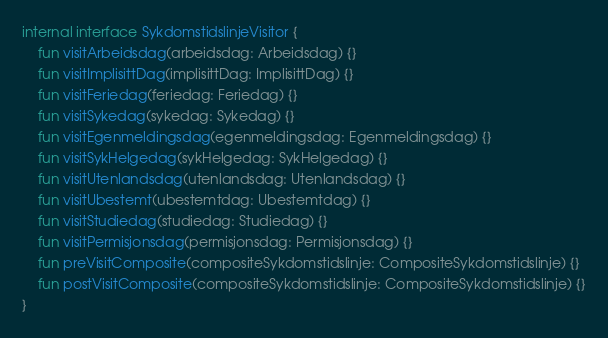Convert code to text. <code><loc_0><loc_0><loc_500><loc_500><_Kotlin_>internal interface SykdomstidslinjeVisitor {
    fun visitArbeidsdag(arbeidsdag: Arbeidsdag) {}
    fun visitImplisittDag(implisittDag: ImplisittDag) {}
    fun visitFeriedag(feriedag: Feriedag) {}
    fun visitSykedag(sykedag: Sykedag) {}
    fun visitEgenmeldingsdag(egenmeldingsdag: Egenmeldingsdag) {}
    fun visitSykHelgedag(sykHelgedag: SykHelgedag) {}
    fun visitUtenlandsdag(utenlandsdag: Utenlandsdag) {}
    fun visitUbestemt(ubestemtdag: Ubestemtdag) {}
    fun visitStudiedag(studiedag: Studiedag) {}
    fun visitPermisjonsdag(permisjonsdag: Permisjonsdag) {}
    fun preVisitComposite(compositeSykdomstidslinje: CompositeSykdomstidslinje) {}
    fun postVisitComposite(compositeSykdomstidslinje: CompositeSykdomstidslinje) {}
}
</code> 